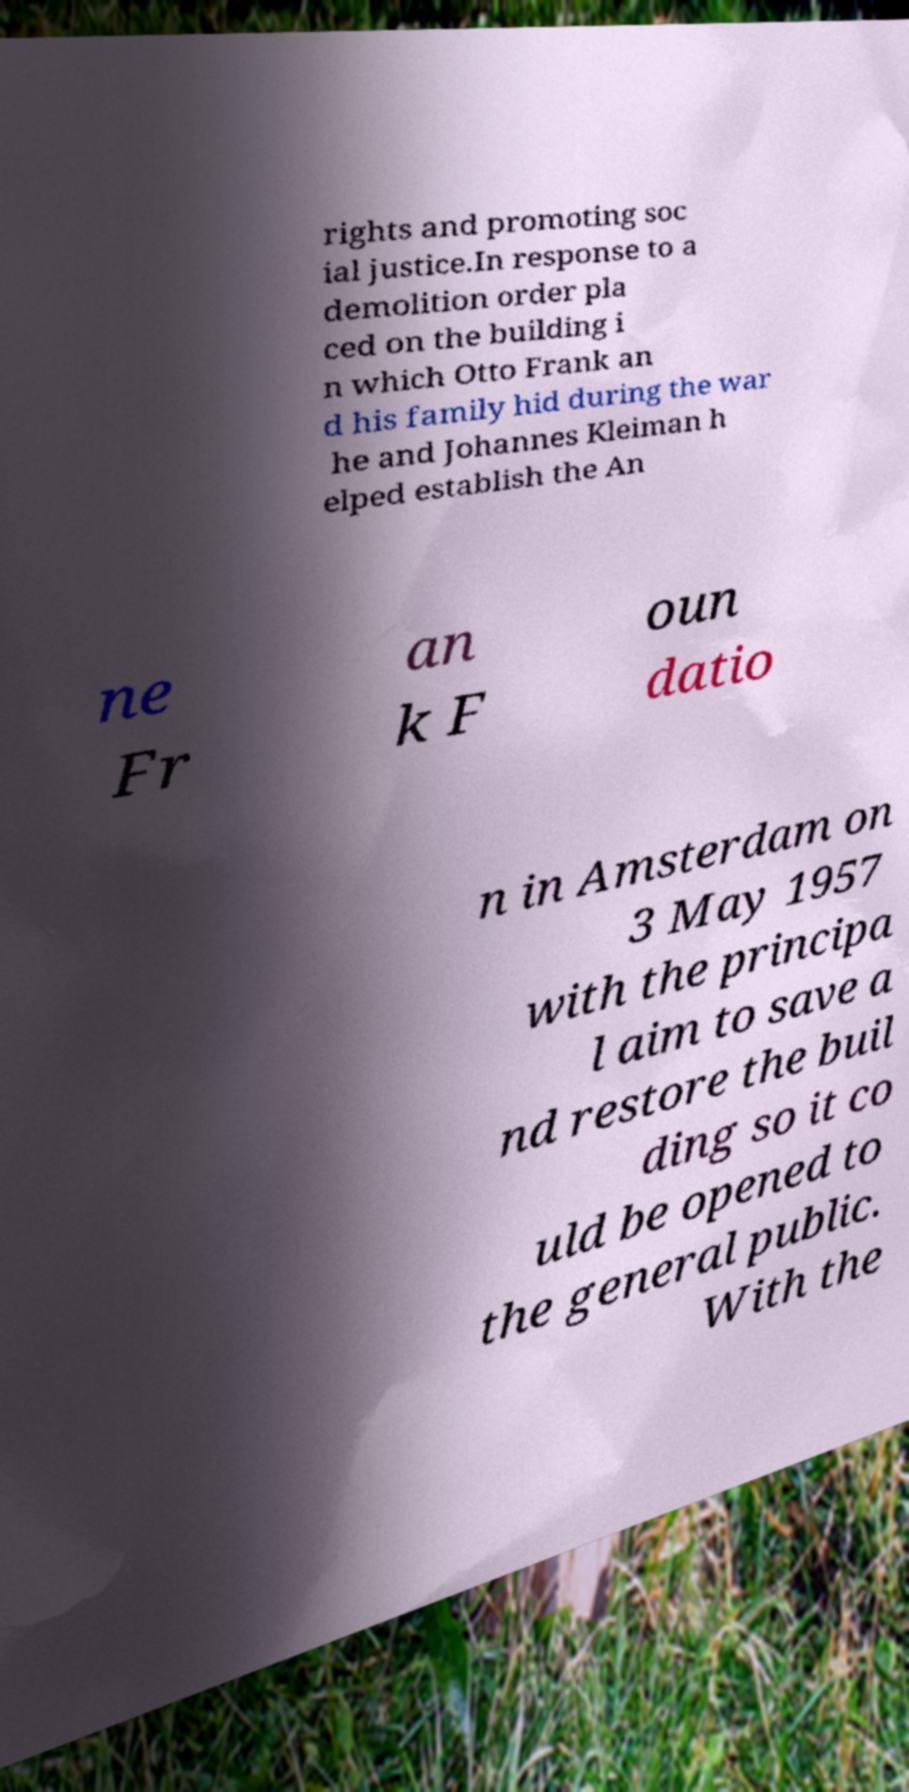What messages or text are displayed in this image? I need them in a readable, typed format. rights and promoting soc ial justice.In response to a demolition order pla ced on the building i n which Otto Frank an d his family hid during the war he and Johannes Kleiman h elped establish the An ne Fr an k F oun datio n in Amsterdam on 3 May 1957 with the principa l aim to save a nd restore the buil ding so it co uld be opened to the general public. With the 